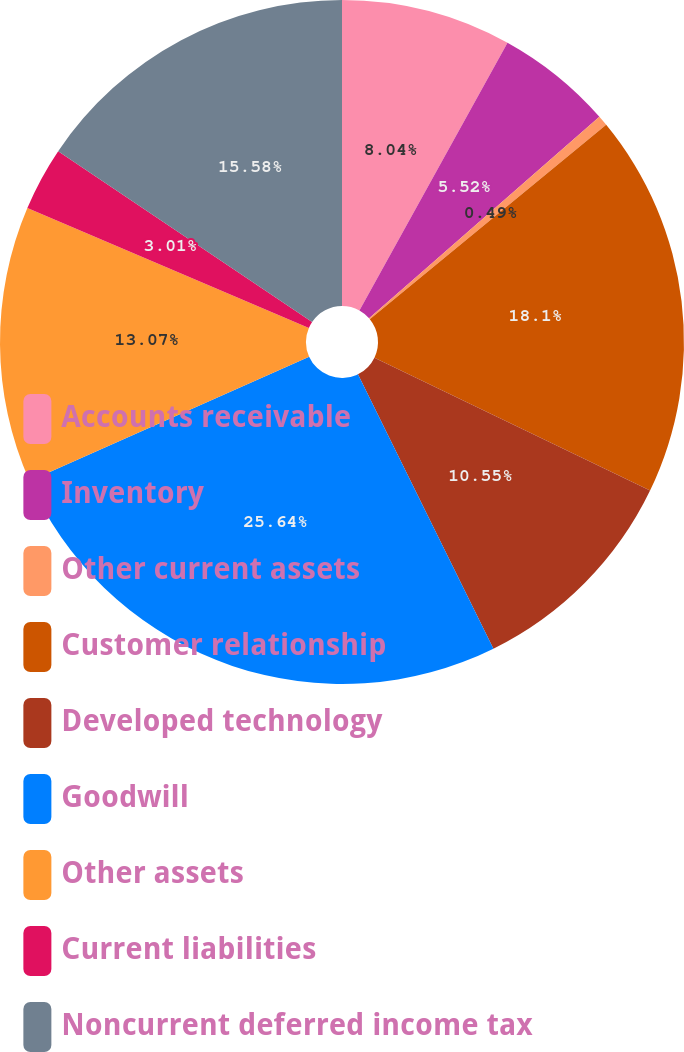<chart> <loc_0><loc_0><loc_500><loc_500><pie_chart><fcel>Accounts receivable<fcel>Inventory<fcel>Other current assets<fcel>Customer relationship<fcel>Developed technology<fcel>Goodwill<fcel>Other assets<fcel>Current liabilities<fcel>Noncurrent deferred income tax<nl><fcel>8.04%<fcel>5.52%<fcel>0.49%<fcel>18.1%<fcel>10.55%<fcel>25.64%<fcel>13.07%<fcel>3.01%<fcel>15.58%<nl></chart> 